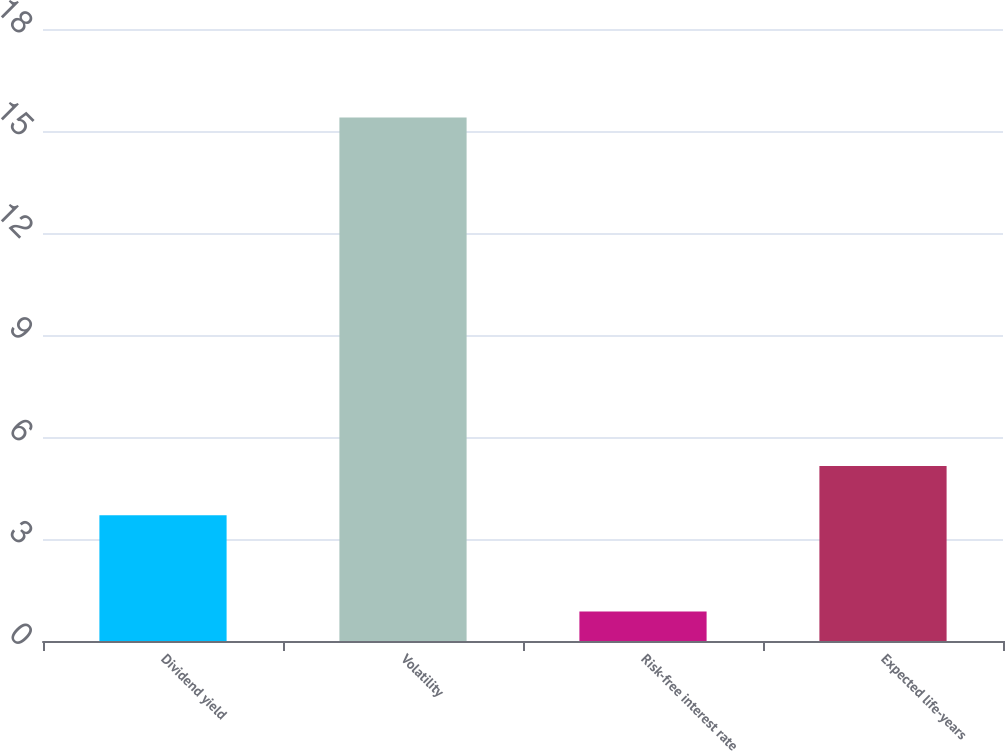<chart> <loc_0><loc_0><loc_500><loc_500><bar_chart><fcel>Dividend yield<fcel>Volatility<fcel>Risk-free interest rate<fcel>Expected life-years<nl><fcel>3.7<fcel>15.4<fcel>0.87<fcel>5.15<nl></chart> 